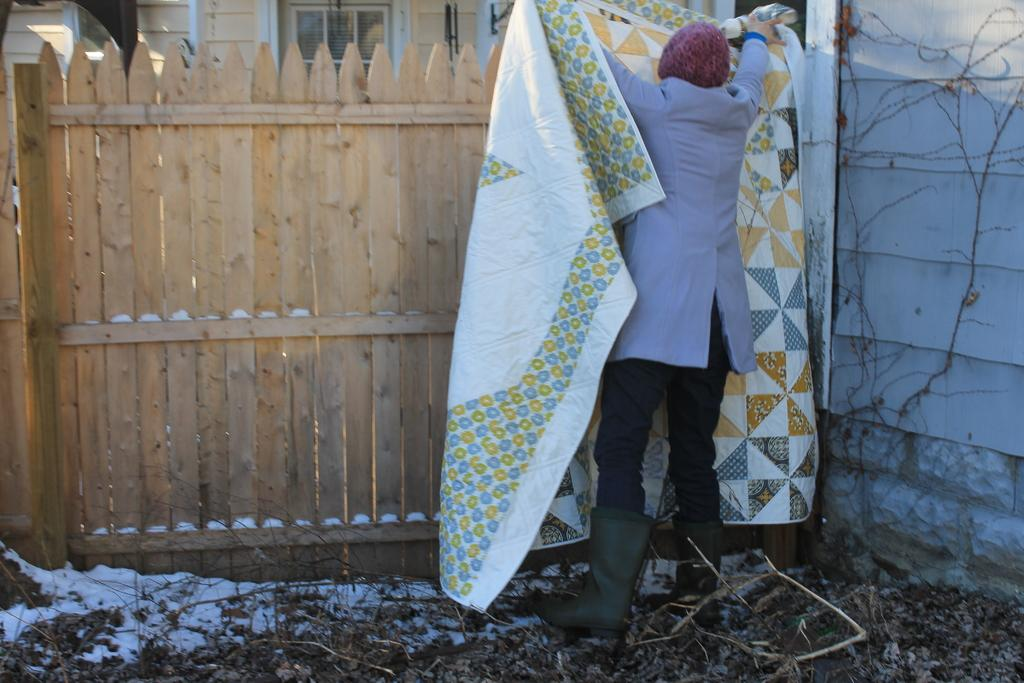What is the main subject of the image? There is a person in the image. What is the person wearing? The person is wearing a dress and a cap. What is the person holding in his hand? The person is holding a cloth in his hand. What can be seen in the background of the image? There is a fence and a building in the background of the image. What type of advertisement can be seen on the person's dress in the image? There is no advertisement visible on the person's dress in the image. What process is the person performing with the cloth in the image? The image does not provide enough information to determine the process being performed with the cloth. 